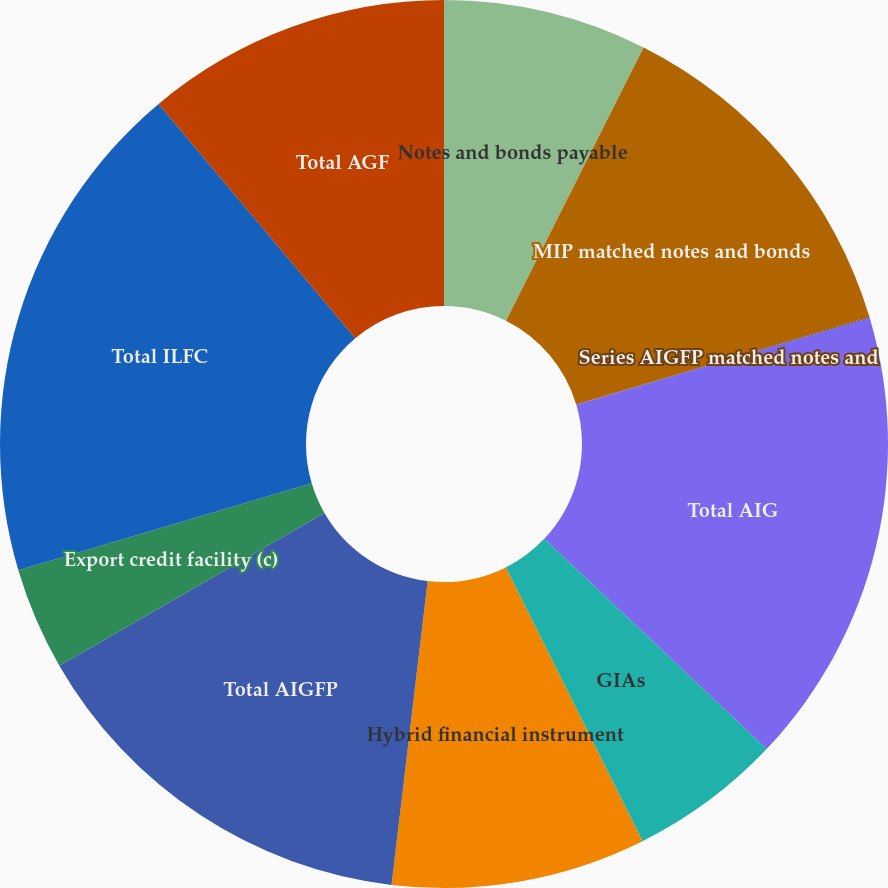<chart> <loc_0><loc_0><loc_500><loc_500><pie_chart><fcel>Notes and bonds payable<fcel>MIP matched notes and bonds<fcel>Series AIGFP matched notes and<fcel>Total AIG<fcel>GIAs<fcel>Hybrid financial instrument<fcel>Total AIGFP<fcel>Export credit facility (c)<fcel>Total ILFC<fcel>Total AGF<nl><fcel>7.42%<fcel>12.95%<fcel>0.04%<fcel>16.64%<fcel>5.57%<fcel>9.26%<fcel>14.79%<fcel>3.73%<fcel>18.48%<fcel>11.11%<nl></chart> 